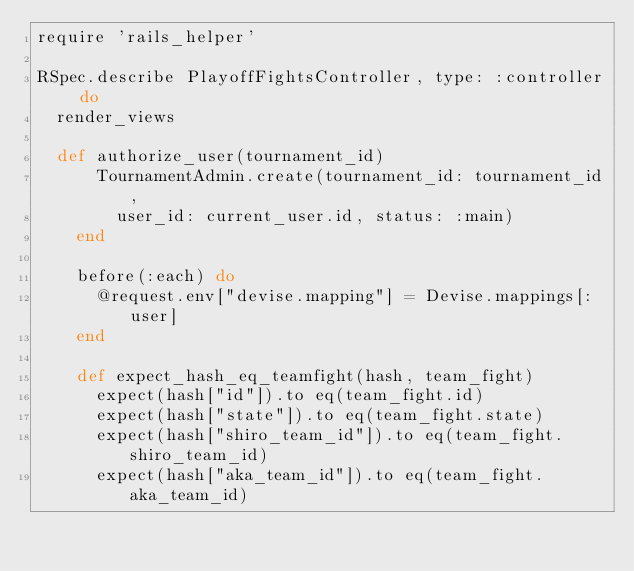<code> <loc_0><loc_0><loc_500><loc_500><_Ruby_>require 'rails_helper'

RSpec.describe PlayoffFightsController, type: :controller do
  render_views

  def authorize_user(tournament_id)
      TournamentAdmin.create(tournament_id: tournament_id,
        user_id: current_user.id, status: :main)
    end

    before(:each) do
      @request.env["devise.mapping"] = Devise.mappings[:user]
    end

    def expect_hash_eq_teamfight(hash, team_fight)
      expect(hash["id"]).to eq(team_fight.id)
      expect(hash["state"]).to eq(team_fight.state)
      expect(hash["shiro_team_id"]).to eq(team_fight.shiro_team_id)
      expect(hash["aka_team_id"]).to eq(team_fight.aka_team_id)</code> 